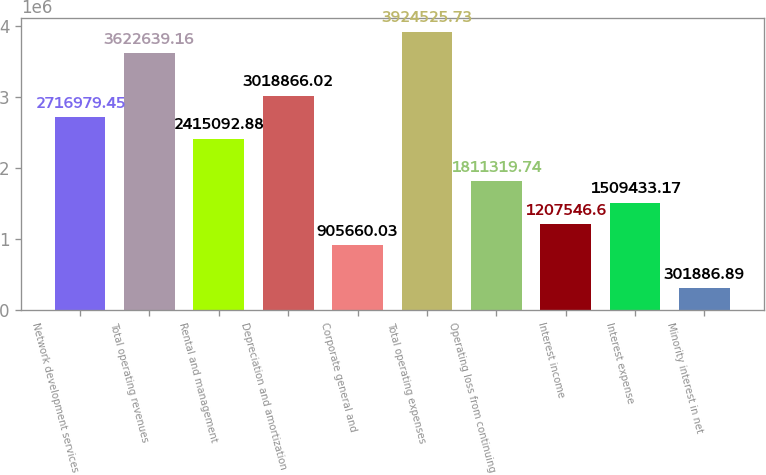<chart> <loc_0><loc_0><loc_500><loc_500><bar_chart><fcel>Network development services<fcel>Total operating revenues<fcel>Rental and management<fcel>Depreciation and amortization<fcel>Corporate general and<fcel>Total operating expenses<fcel>Operating loss from continuing<fcel>Interest income<fcel>Interest expense<fcel>Minority interest in net<nl><fcel>2.71698e+06<fcel>3.62264e+06<fcel>2.41509e+06<fcel>3.01887e+06<fcel>905660<fcel>3.92453e+06<fcel>1.81132e+06<fcel>1.20755e+06<fcel>1.50943e+06<fcel>301887<nl></chart> 